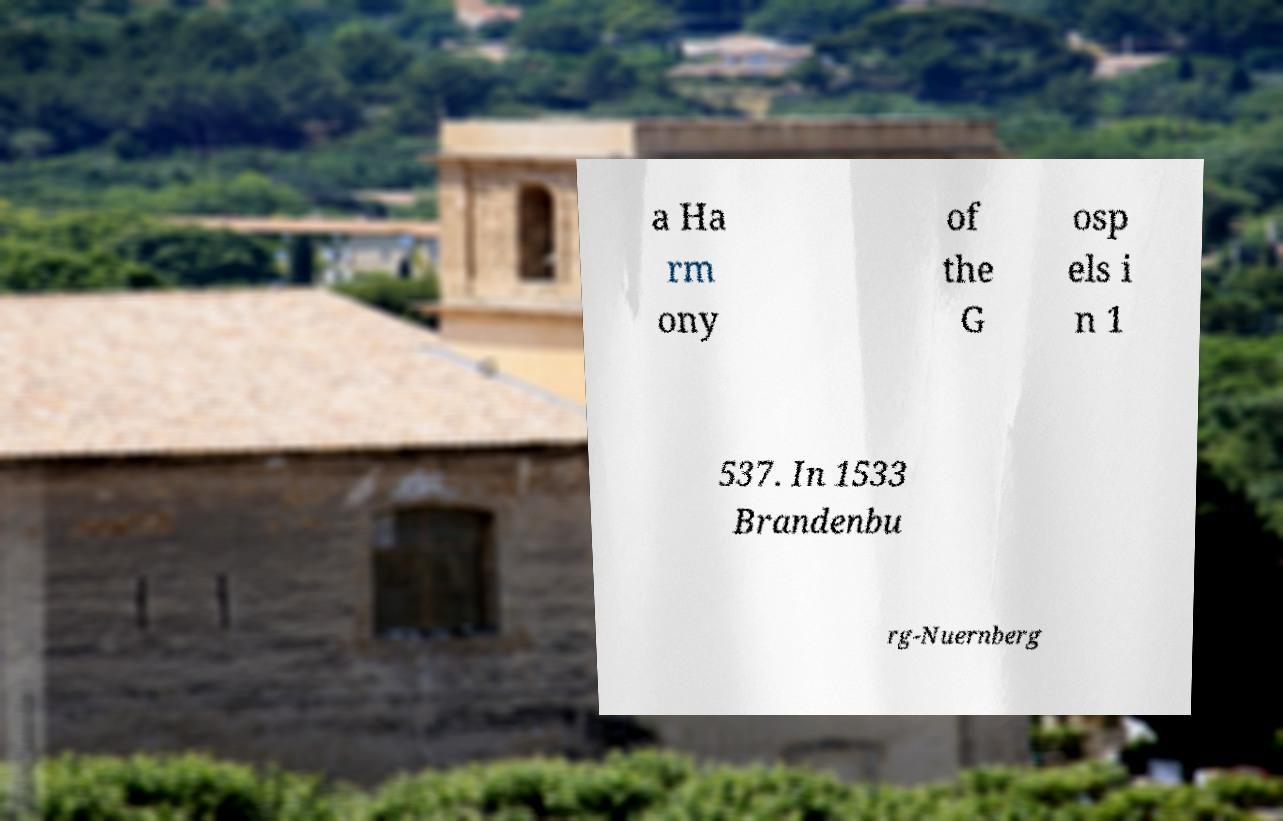Please read and relay the text visible in this image. What does it say? a Ha rm ony of the G osp els i n 1 537. In 1533 Brandenbu rg-Nuernberg 